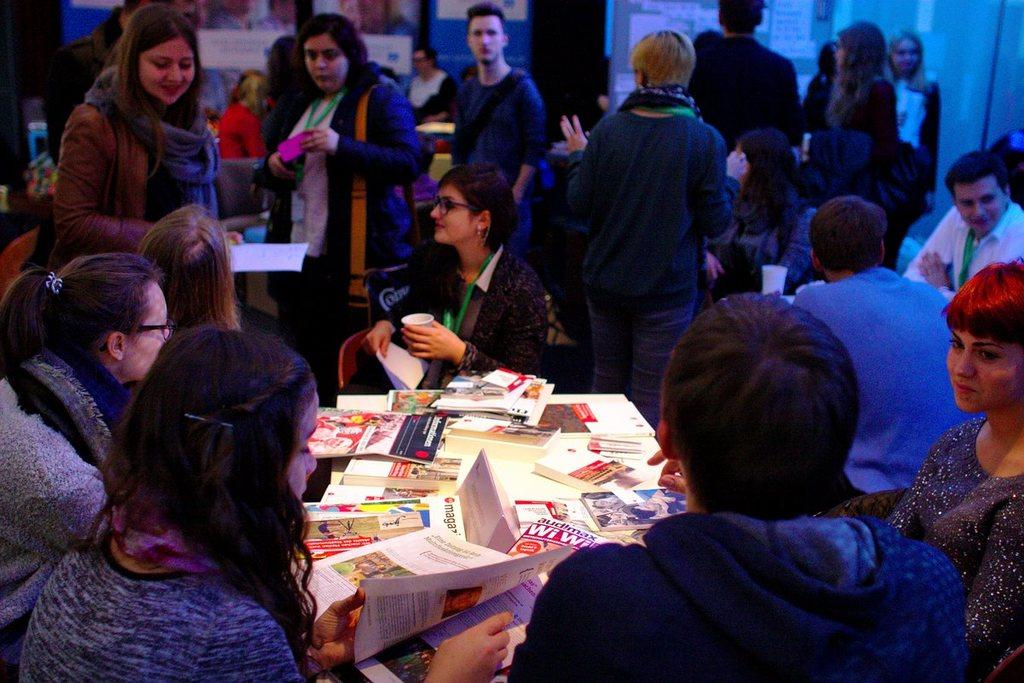What is the general activity of the people in the image? There are many people standing and sitting in the image. What object can be seen in the image besides the people? There is a table in the image. What items are placed on the table? There are books placed on the table. How does the thing breathe in the image? There is no thing present in the image, and therefore no breathing can be observed. 